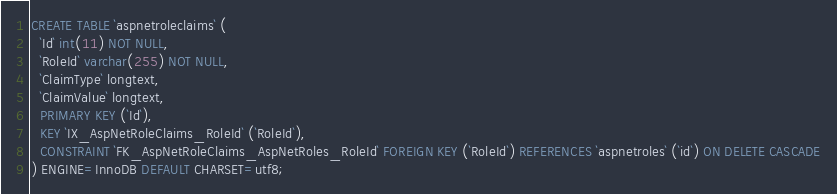Convert code to text. <code><loc_0><loc_0><loc_500><loc_500><_SQL_>CREATE TABLE `aspnetroleclaims` (
  `Id` int(11) NOT NULL,
  `RoleId` varchar(255) NOT NULL,
  `ClaimType` longtext,
  `ClaimValue` longtext,
  PRIMARY KEY (`Id`),
  KEY `IX_AspNetRoleClaims_RoleId` (`RoleId`),
  CONSTRAINT `FK_AspNetRoleClaims_AspNetRoles_RoleId` FOREIGN KEY (`RoleId`) REFERENCES `aspnetroles` (`id`) ON DELETE CASCADE
) ENGINE=InnoDB DEFAULT CHARSET=utf8;
</code> 